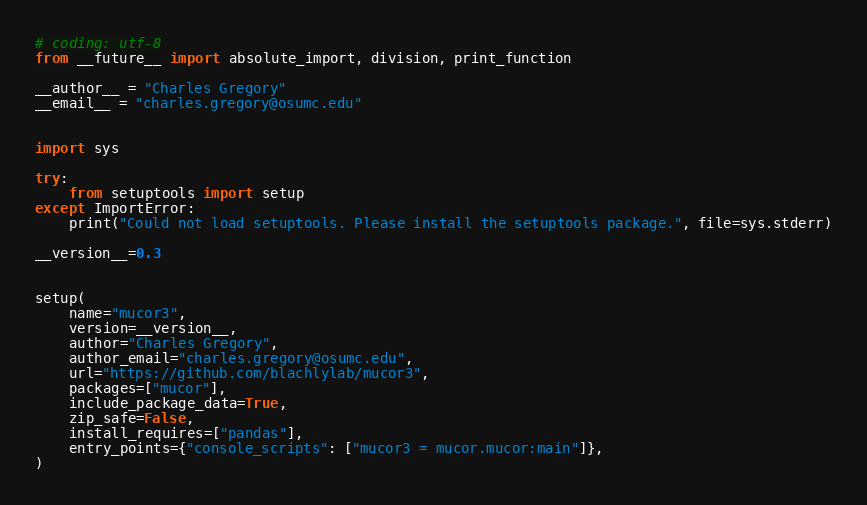Convert code to text. <code><loc_0><loc_0><loc_500><loc_500><_Python_># coding: utf-8
from __future__ import absolute_import, division, print_function

__author__ = "Charles Gregory"
__email__ = "charles.gregory@osumc.edu"


import sys

try:
    from setuptools import setup
except ImportError:
    print("Could not load setuptools. Please install the setuptools package.", file=sys.stderr)

__version__=0.3


setup(
    name="mucor3",
    version=__version__,
    author="Charles Gregory",
    author_email="charles.gregory@osumc.edu",
    url="https://github.com/blachlylab/mucor3",
    packages=["mucor"],
    include_package_data=True,
    zip_safe=False,
    install_requires=["pandas"],
    entry_points={"console_scripts": ["mucor3 = mucor.mucor:main"]},
)
</code> 